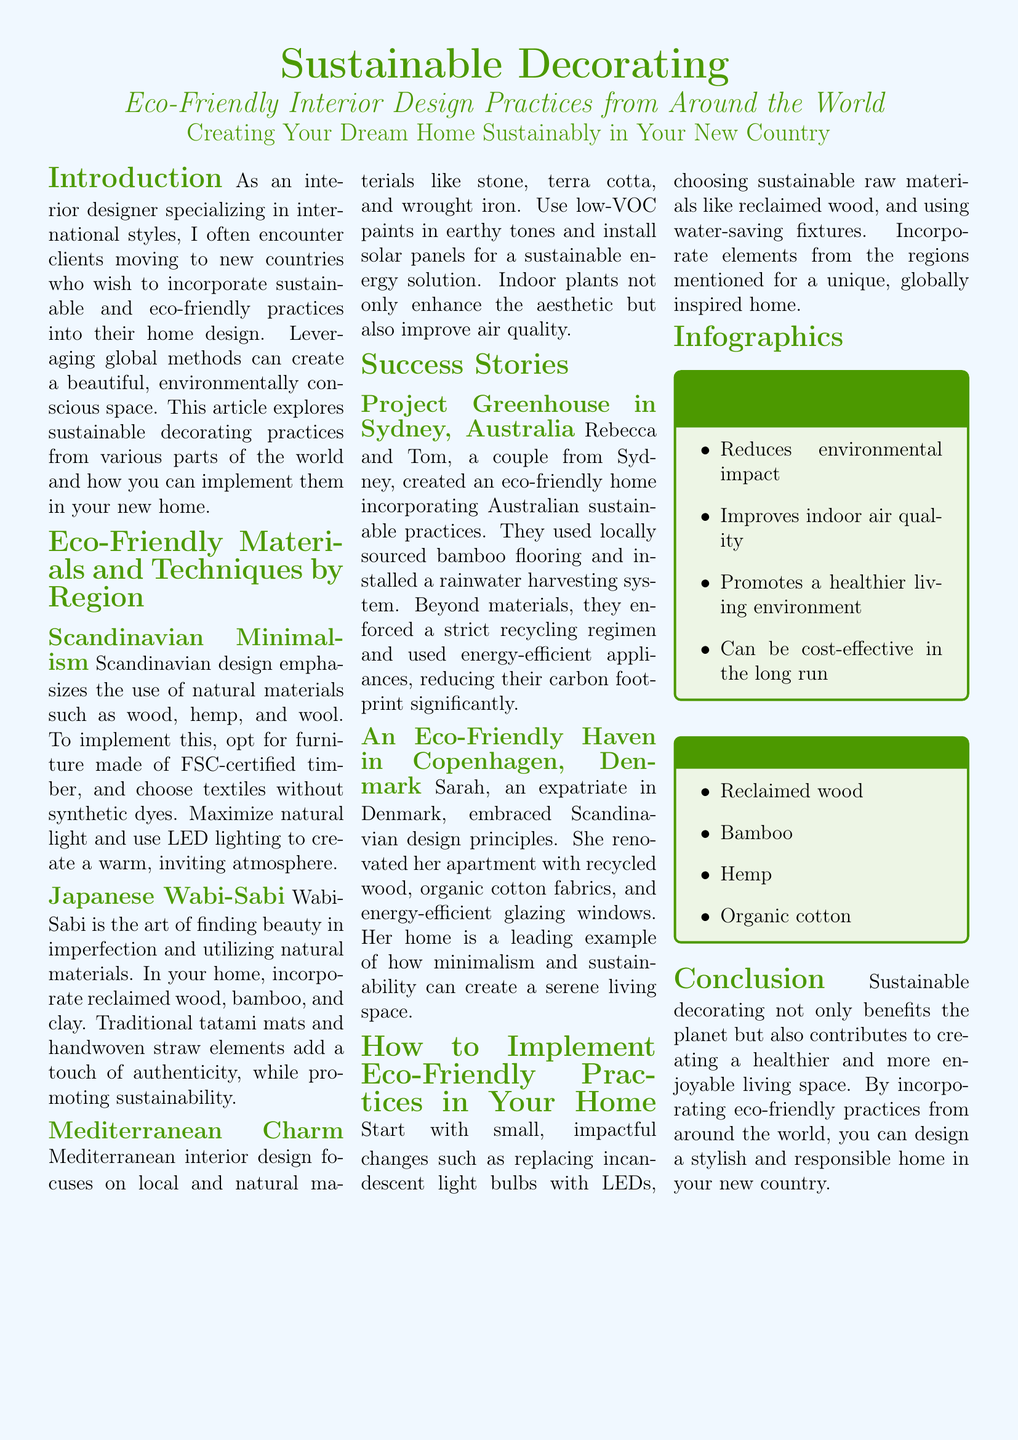what is the focus of Scandinavian design? The document states that Scandinavian design emphasizes the use of natural materials such as wood, hemp, and wool.
Answer: natural materials what materials are recommended for Japanese Wabi-Sabi design? The document lists reclaimed wood, bamboo, and clay as recommended materials for Wabi-Sabi design.
Answer: reclaimed wood, bamboo, clay which city is the Project Greenhouse located in? The success story titled "Project Greenhouse" is based in Sydney, Australia.
Answer: Sydney what are some benefits of sustainable decorating according to the infographic? The infographic points out benefits such as reducing environmental impact and improving indoor air quality.
Answer: reduces environmental impact, improves indoor air quality what type of practices did Sarah implement in her Copenhagen apartment? Sarah embraced Scandinavian design principles using recycled wood, organic cotton fabrics, and energy-efficient glazing windows.
Answer: recycled wood, organic cotton fabrics, energy-efficient glazing windows what is a small change recommended for implementing eco-friendly practices? The document suggests replacing incandescent light bulbs with LEDs as a small change.
Answer: replacing incandescent light bulbs with LEDs how many sections are there in the document? The document contains six main sections in addition to the introduction and conclusion.
Answer: six what type of materials are listed as top eco-friendly materials? The document lists reclaimed wood, bamboo, hemp, and organic cotton as top eco-friendly materials.
Answer: reclaimed wood, bamboo, hemp, organic cotton 